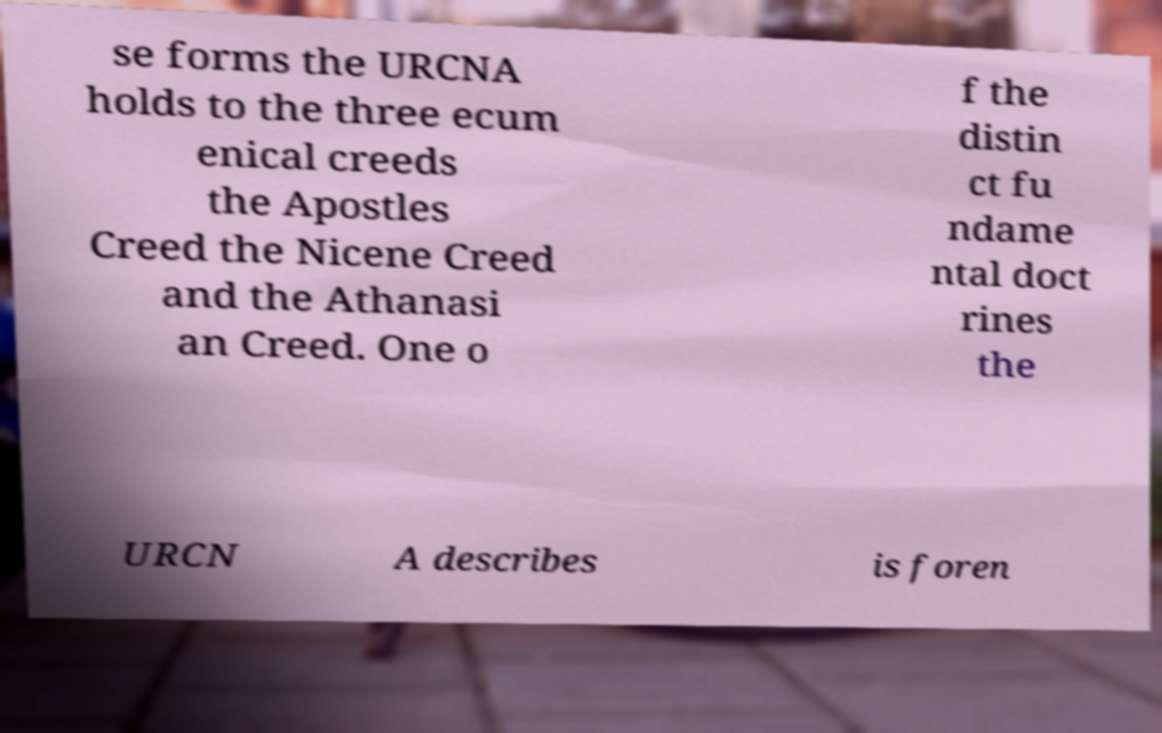Please read and relay the text visible in this image. What does it say? se forms the URCNA holds to the three ecum enical creeds the Apostles Creed the Nicene Creed and the Athanasi an Creed. One o f the distin ct fu ndame ntal doct rines the URCN A describes is foren 